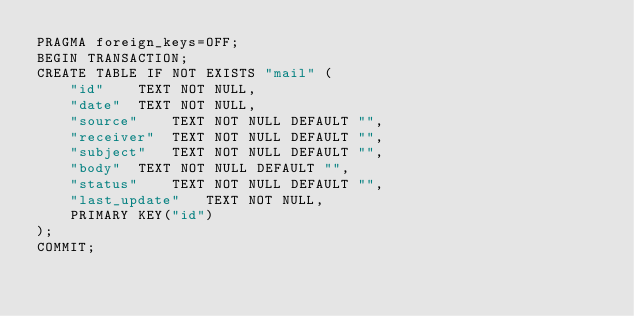Convert code to text. <code><loc_0><loc_0><loc_500><loc_500><_SQL_>PRAGMA foreign_keys=OFF;
BEGIN TRANSACTION;
CREATE TABLE IF NOT EXISTS "mail" (
	"id"	TEXT NOT NULL,
	"date"	TEXT NOT NULL,
	"source"	TEXT NOT NULL DEFAULT "",
	"receiver"	TEXT NOT NULL DEFAULT "",
	"subject"	TEXT NOT NULL DEFAULT "",
	"body"	TEXT NOT NULL DEFAULT "",
	"status"	TEXT NOT NULL DEFAULT "",
	"last_update"	TEXT NOT NULL,
	PRIMARY KEY("id")
);
COMMIT;
</code> 